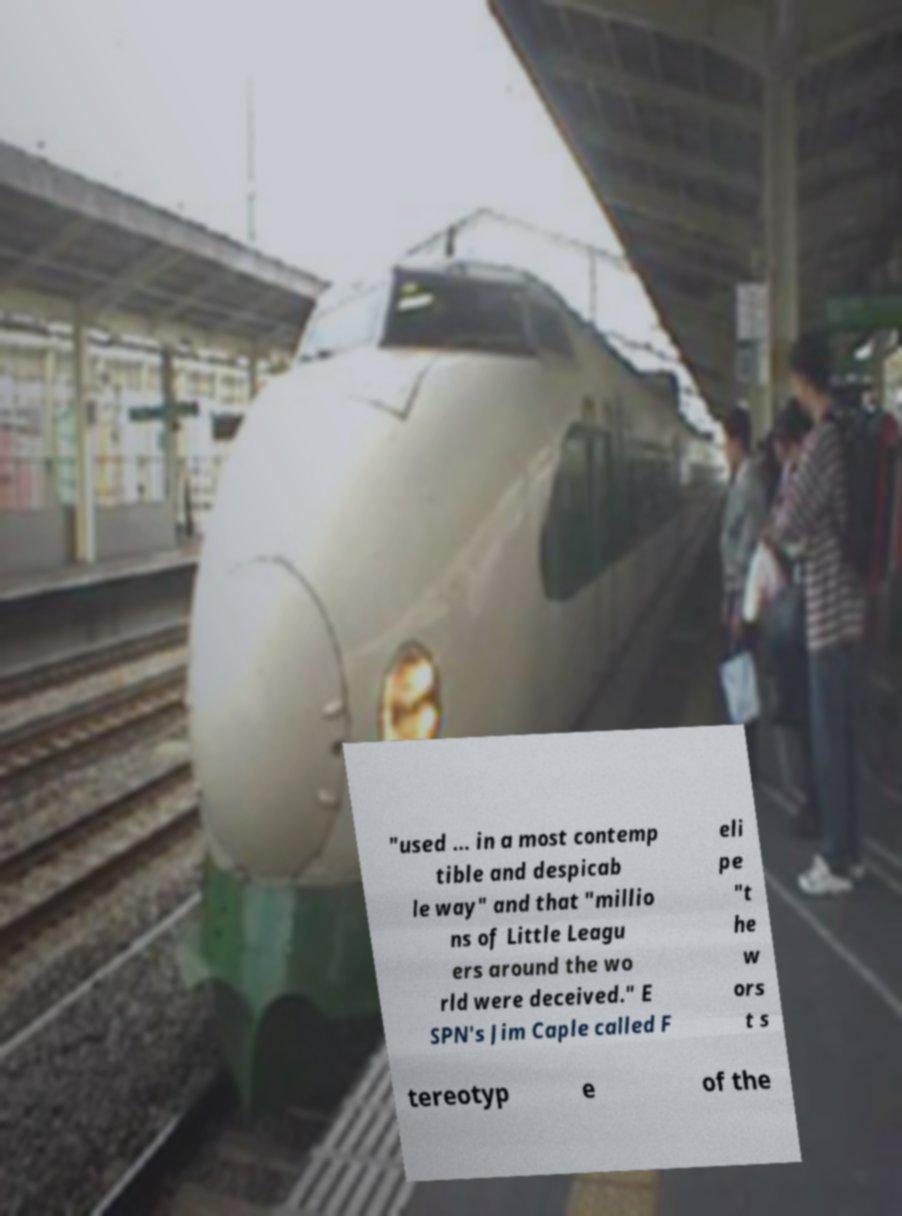Can you accurately transcribe the text from the provided image for me? "used ... in a most contemp tible and despicab le way" and that "millio ns of Little Leagu ers around the wo rld were deceived." E SPN's Jim Caple called F eli pe "t he w ors t s tereotyp e of the 